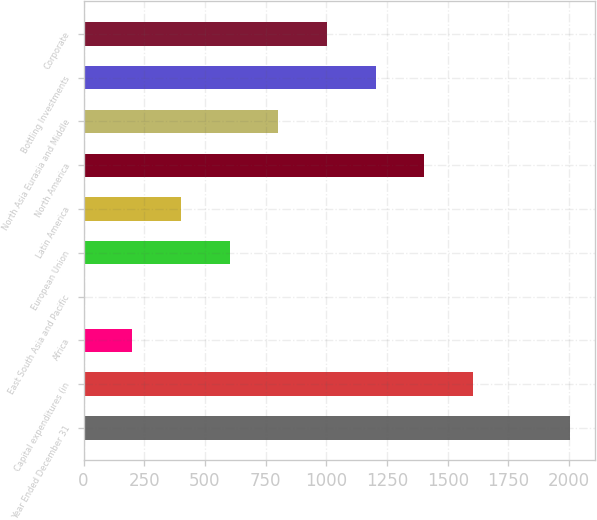<chart> <loc_0><loc_0><loc_500><loc_500><bar_chart><fcel>Year Ended December 31<fcel>Capital expenditures (in<fcel>Africa<fcel>East South Asia and Pacific<fcel>European Union<fcel>Latin America<fcel>North America<fcel>North Asia Eurasia and Middle<fcel>Bottling Investments<fcel>Corporate<nl><fcel>2005<fcel>1604.16<fcel>201.22<fcel>0.8<fcel>602.06<fcel>401.64<fcel>1403.74<fcel>802.48<fcel>1203.32<fcel>1002.9<nl></chart> 